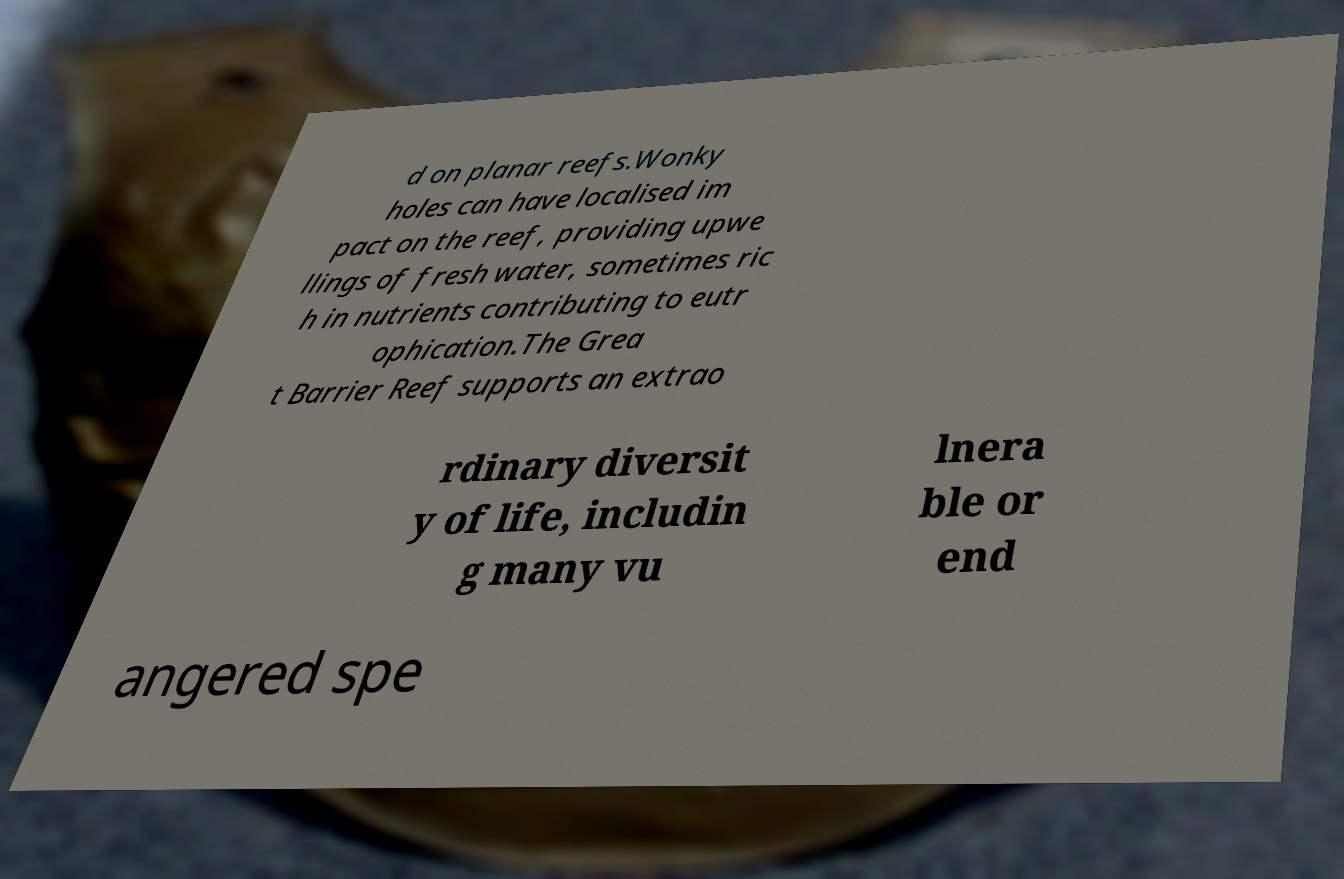For documentation purposes, I need the text within this image transcribed. Could you provide that? d on planar reefs.Wonky holes can have localised im pact on the reef, providing upwe llings of fresh water, sometimes ric h in nutrients contributing to eutr ophication.The Grea t Barrier Reef supports an extrao rdinary diversit y of life, includin g many vu lnera ble or end angered spe 